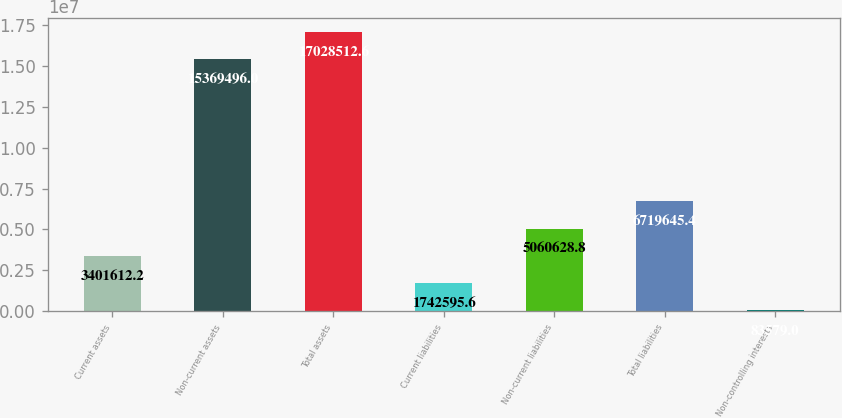<chart> <loc_0><loc_0><loc_500><loc_500><bar_chart><fcel>Current assets<fcel>Non-current assets<fcel>Total assets<fcel>Current liabilities<fcel>Non-current liabilities<fcel>Total liabilities<fcel>Non-controlling interests<nl><fcel>3.40161e+06<fcel>1.53695e+07<fcel>1.70285e+07<fcel>1.7426e+06<fcel>5.06063e+06<fcel>6.71965e+06<fcel>83579<nl></chart> 